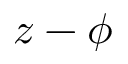<formula> <loc_0><loc_0><loc_500><loc_500>z - \phi</formula> 